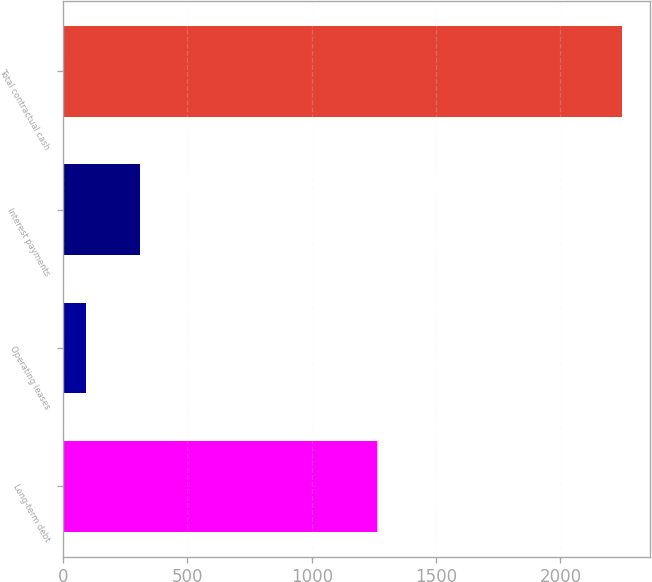Convert chart. <chart><loc_0><loc_0><loc_500><loc_500><bar_chart><fcel>Long-term debt<fcel>Operating leases<fcel>Interest payments<fcel>Total contractual cash<nl><fcel>1262.4<fcel>94.3<fcel>309.46<fcel>2245.9<nl></chart> 